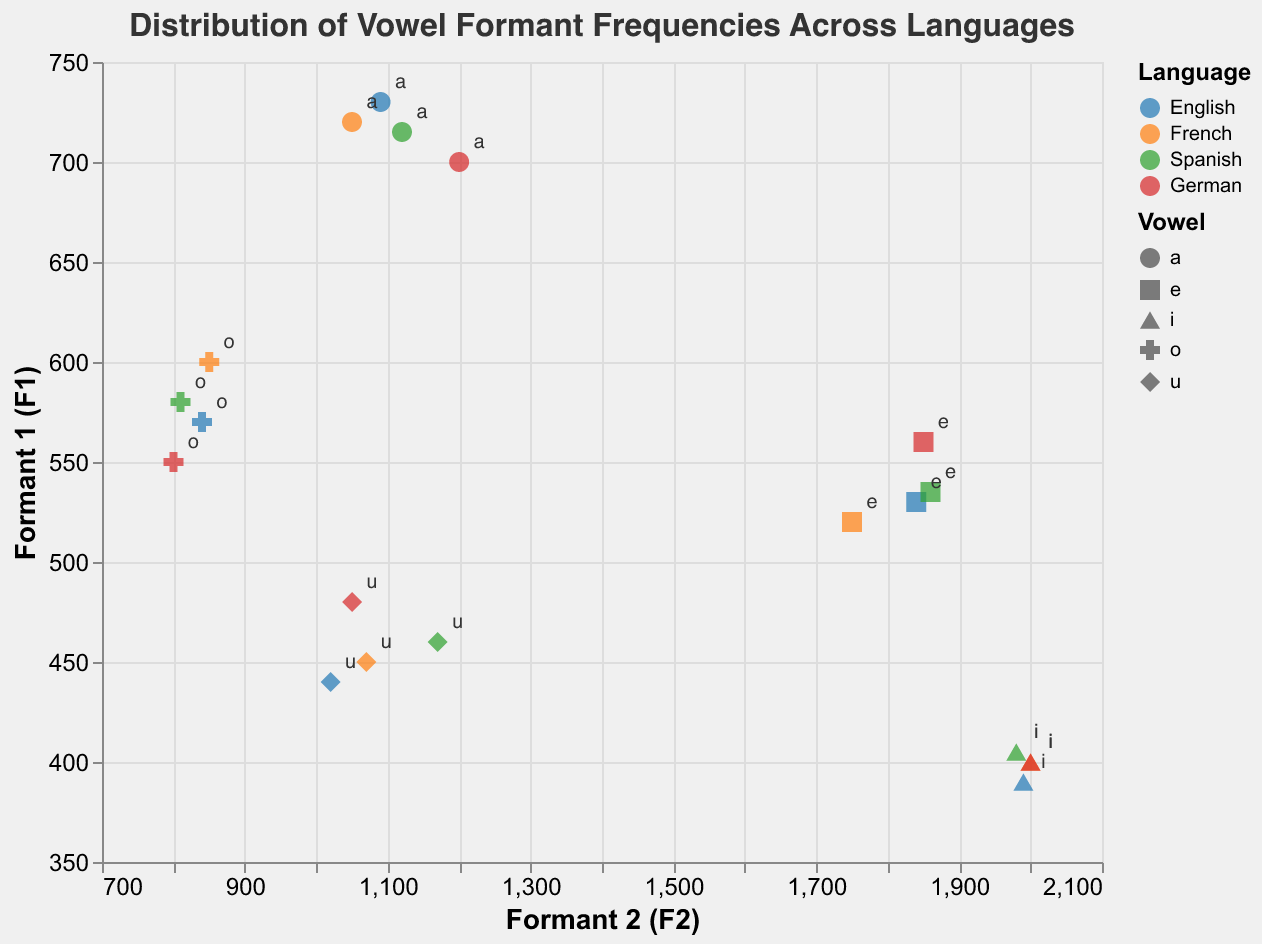What is the title of the plot? The title of the plot is usually found at the top center of the figure. In this case, it reads "Distribution of Vowel Formant Frequencies Across Languages".
Answer: Distribution of Vowel Formant Frequencies Across Languages Which language has the vowel 'i' with the highest F2 value? To answer this, we need to scan the plot for the vowel 'i' in each language and find the one with the highest F2 value, which is indicated on the x-axis. The relevant point is for "English" with an F2 value of 1990.
Answer: English How many vowel points are there for the German language? Each language has 5 vowels ('a', 'e', 'i', 'o', 'u'). This means for German, we should have 5 points plotted.
Answer: 5 Compare the F1 and F2 values of the vowel 'a' in English and French. Which has a higher F2 value? Locate the points for the vowel 'a' for both English and French. For English, 'a' has an F2 of 1090; for French, it is 1050. Therefore, English 'a' has a higher F2 value.
Answer: English Which vowel in Spanish has the lowest F1 value and what is the value? We need to locate all Spanish vowels and find the one with the lowest y-axis value, which represents F1. The vowel 'i' has the lowest F1 value of 405.
Answer: i, 405 Identify the language and vowel with the highest F1 value on the plot. Scan through the y-axis to find the point that has the highest F1 value. The vowel 'a' in English, with a value of 730, has the highest F1.
Answer: English, a Which vowel in French has an F2 value closest to 850? Look for the points labeled with French vowels. The vowel 'o' in French has an F2 of 850.
Answer: o Calculate the average F1 value of the 'u' vowel across all languages. Add the F1 values for the vowel 'u' from all four languages: (440+450+460+480) = 1830. The average F1 is obtained by dividing by 4, thus 1830/4 = 457.5.
Answer: 457.5 Which language displays the greatest variance in F1 values for its vowels? By comparing the spread of the y-axis values for each language category, German appears to have vowels spanning from 400 to 700, indicating the greatest variance.
Answer: German 